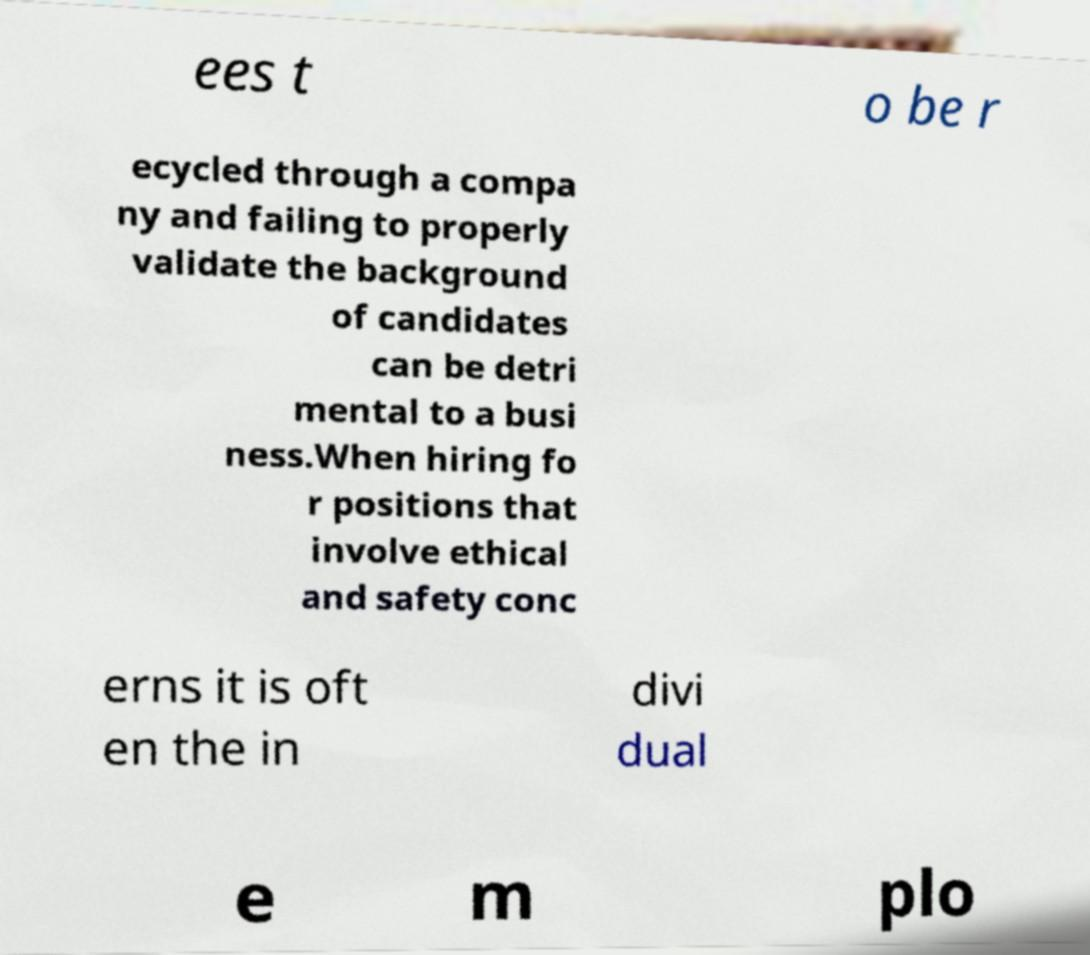Can you read and provide the text displayed in the image?This photo seems to have some interesting text. Can you extract and type it out for me? ees t o be r ecycled through a compa ny and failing to properly validate the background of candidates can be detri mental to a busi ness.When hiring fo r positions that involve ethical and safety conc erns it is oft en the in divi dual e m plo 